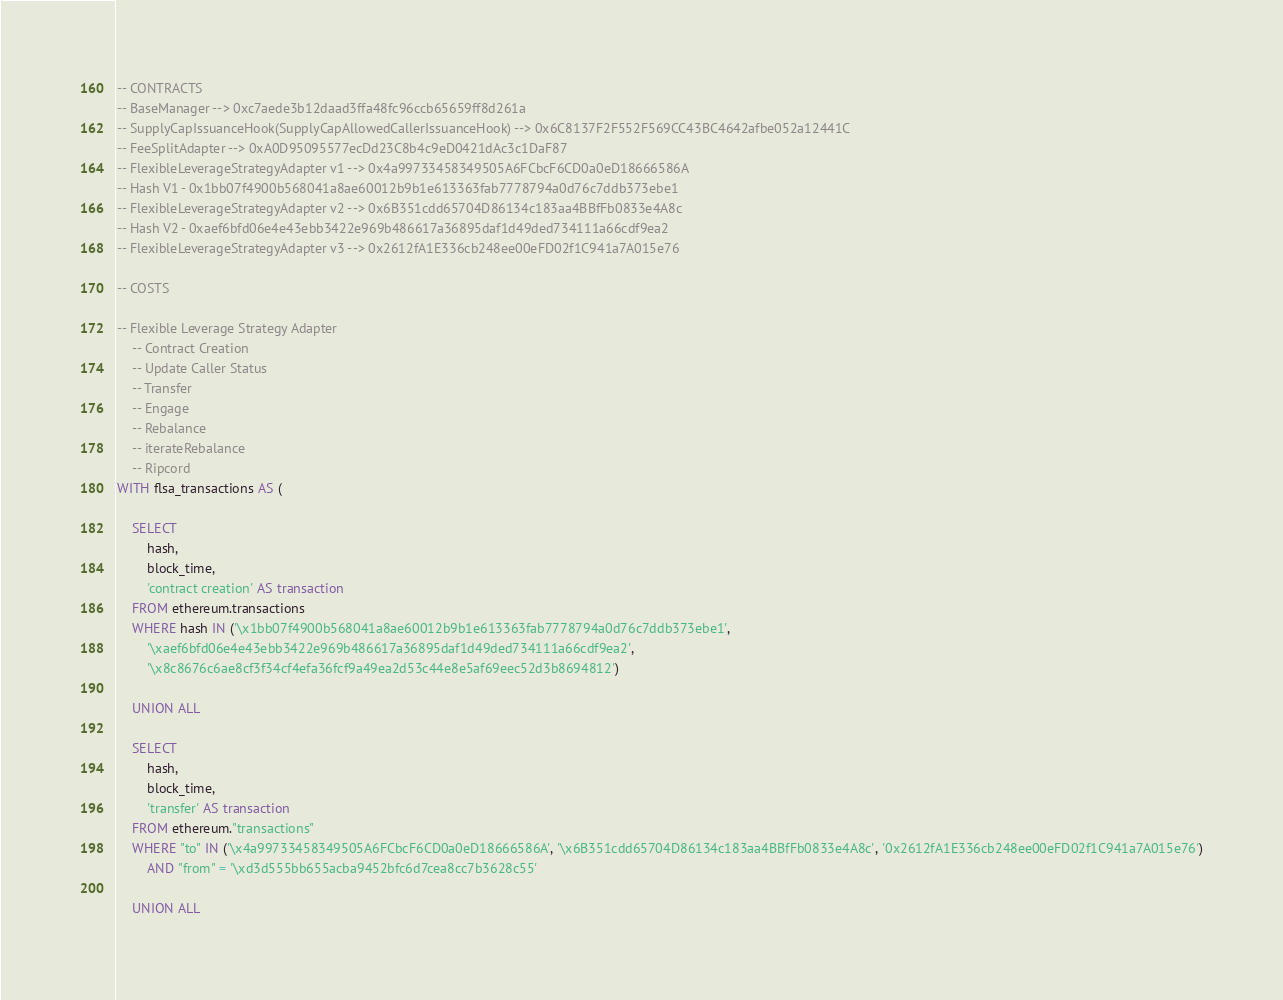<code> <loc_0><loc_0><loc_500><loc_500><_SQL_>-- CONTRACTS
-- BaseManager --> 0xc7aede3b12daad3ffa48fc96ccb65659ff8d261a
-- SupplyCapIssuanceHook(SupplyCapAllowedCallerIssuanceHook) --> 0x6C8137F2F552F569CC43BC4642afbe052a12441C
-- FeeSplitAdapter --> 0xA0D95095577ecDd23C8b4c9eD0421dAc3c1DaF87
-- FlexibleLeverageStrategyAdapter v1 --> 0x4a99733458349505A6FCbcF6CD0a0eD18666586A
-- Hash V1 - 0x1bb07f4900b568041a8ae60012b9b1e613363fab7778794a0d76c7ddb373ebe1
-- FlexibleLeverageStrategyAdapter v2 --> 0x6B351cdd65704D86134c183aa4BBfFb0833e4A8c
-- Hash V2 - 0xaef6bfd06e4e43ebb3422e969b486617a36895daf1d49ded734111a66cdf9ea2
-- FlexibleLeverageStrategyAdapter v3 --> 0x2612fA1E336cb248ee00eFD02f1C941a7A015e76

-- COSTS

-- Flexible Leverage Strategy Adapter
    -- Contract Creation
    -- Update Caller Status
    -- Transfer
    -- Engage
    -- Rebalance
    -- iterateRebalance
    -- Ripcord
WITH flsa_transactions AS (

    SELECT
        hash,
        block_time,
        'contract creation' AS transaction
    FROM ethereum.transactions
    WHERE hash IN ('\x1bb07f4900b568041a8ae60012b9b1e613363fab7778794a0d76c7ddb373ebe1',
        '\xaef6bfd06e4e43ebb3422e969b486617a36895daf1d49ded734111a66cdf9ea2', 
        '\x8c8676c6ae8cf3f34cf4efa36fcf9a49ea2d53c44e8e5af69eec52d3b8694812')
    
    UNION ALL
    
    SELECT
        hash,
        block_time,
        'transfer' AS transaction
    FROM ethereum."transactions"
    WHERE "to" IN ('\x4a99733458349505A6FCbcF6CD0a0eD18666586A', '\x6B351cdd65704D86134c183aa4BBfFb0833e4A8c', '0x2612fA1E336cb248ee00eFD02f1C941a7A015e76')
        AND "from" = '\xd3d555bb655acba9452bfc6d7cea8cc7b3628c55'
    
    UNION ALL</code> 